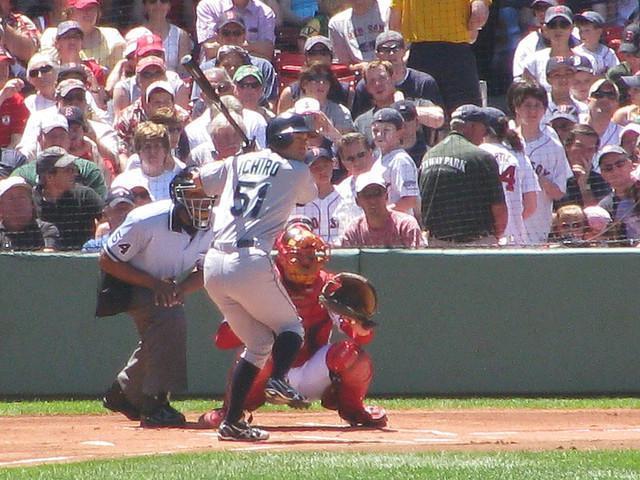What is the net in front of the spectators there for?
Choose the correct response and explain in the format: 'Answer: answer
Rationale: rationale.'
Options: Stop ball, chicken pen, player captivity, punishment. Answer: stop ball.
Rationale: The net prevents bystanders from getting hurt if a ball comes flying over the wall. 